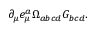Convert formula to latex. <formula><loc_0><loc_0><loc_500><loc_500>\partial _ { \mu } e _ { \mu } ^ { a } \Omega _ { a b c d } G _ { b c d } .</formula> 